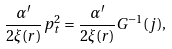<formula> <loc_0><loc_0><loc_500><loc_500>\frac { \alpha ^ { \prime } } { 2 \xi ( r ) } p _ { t } ^ { 2 } = \frac { \alpha ^ { \prime } } { 2 \xi ( r ) } G ^ { - 1 } ( j ) ,</formula> 